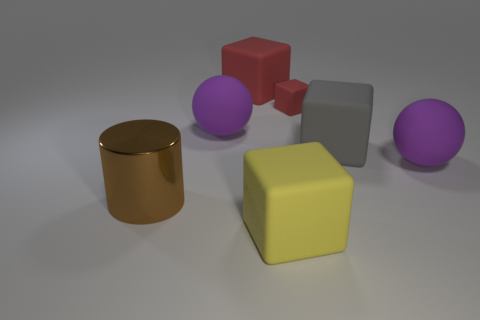Subtract all large yellow blocks. How many blocks are left? 3 Subtract all green cylinders. How many red cubes are left? 2 Add 1 tiny red rubber objects. How many objects exist? 8 Subtract all red cubes. How many cubes are left? 2 Subtract all yellow blocks. Subtract all green cylinders. How many blocks are left? 3 Subtract all balls. How many objects are left? 5 Add 1 big spheres. How many big spheres exist? 3 Subtract 0 yellow cylinders. How many objects are left? 7 Subtract all tiny brown things. Subtract all big yellow rubber cubes. How many objects are left? 6 Add 2 big red things. How many big red things are left? 3 